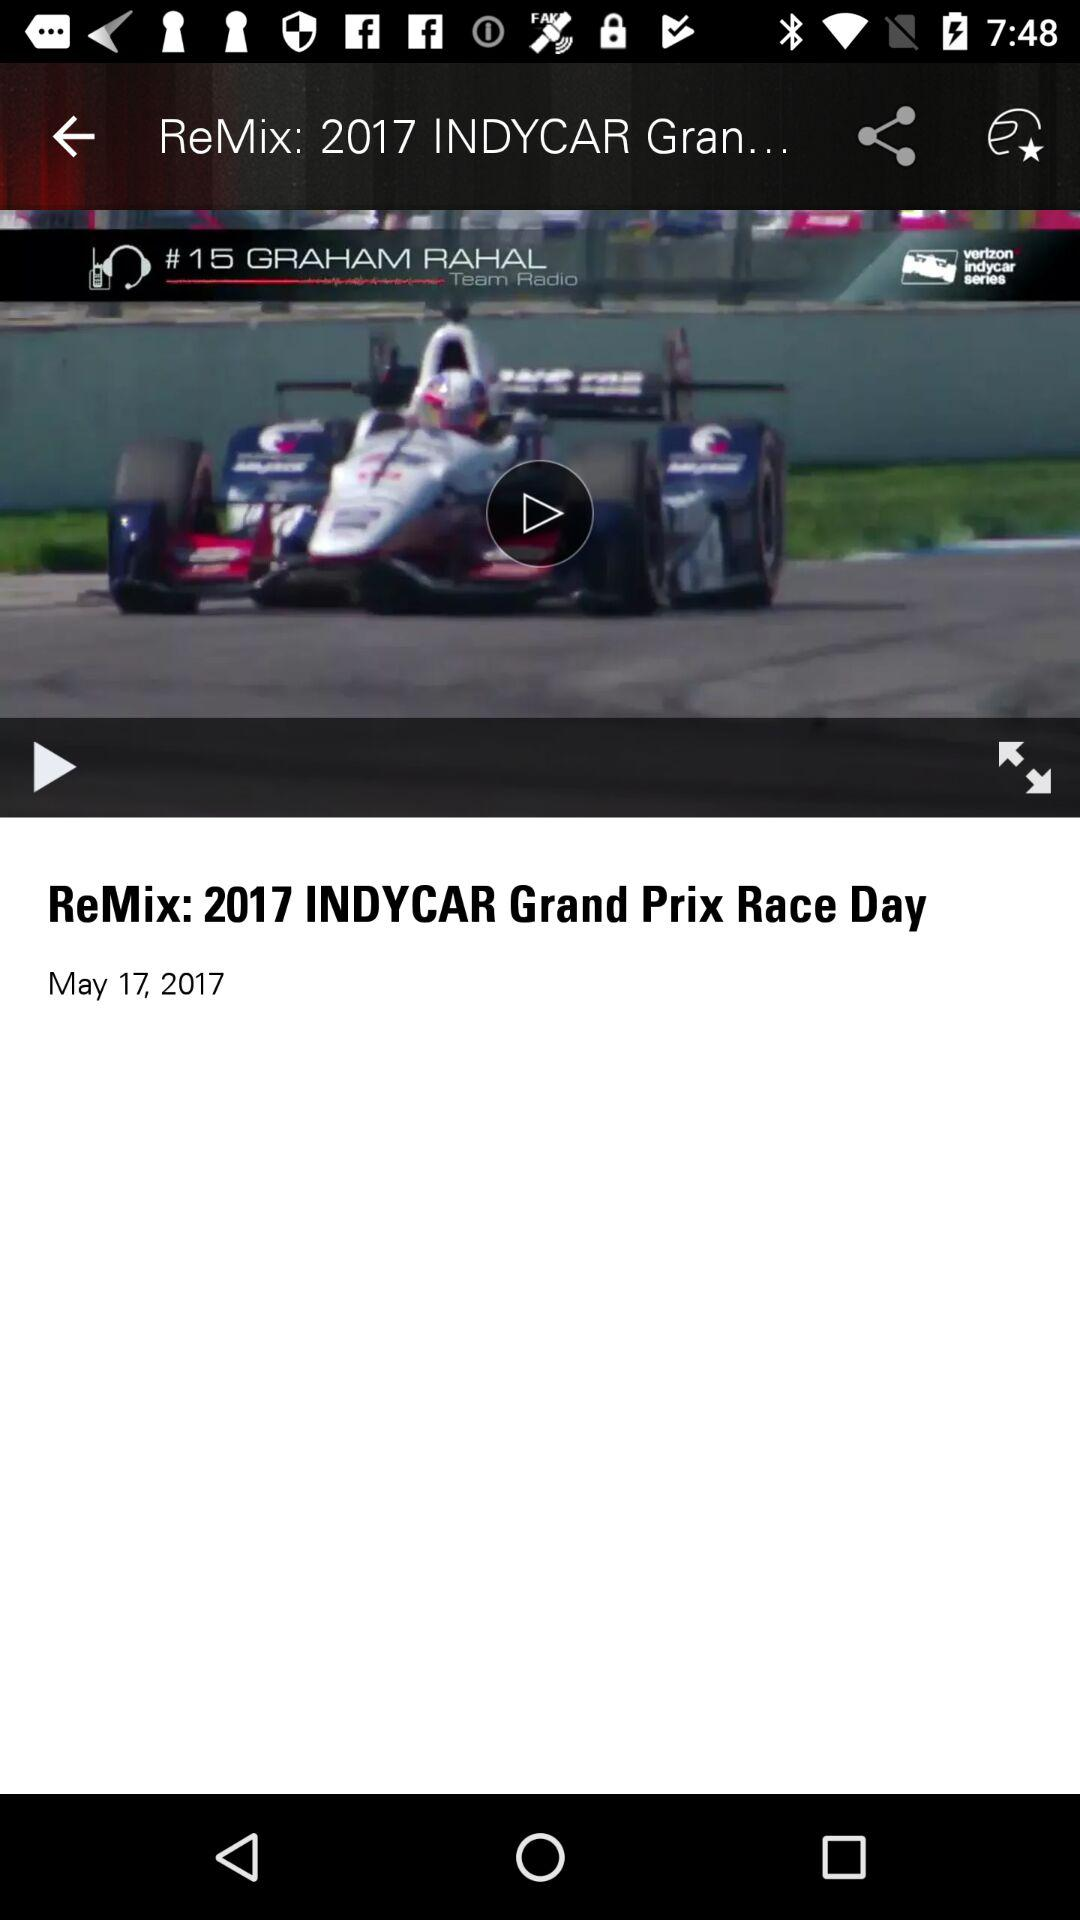What video was last played? The last played video was "ReMix: 2017 INDYCAR Grand Prix Race Day". 